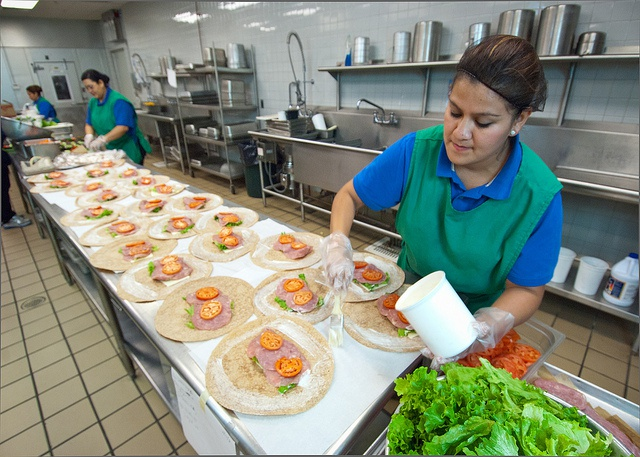Describe the objects in this image and their specific colors. I can see dining table in black, lightgray, tan, and gray tones, people in black, teal, and blue tones, cup in black, white, lightblue, darkgray, and lightgray tones, people in black, teal, and blue tones, and sink in black, gray, darkgray, and lightgray tones in this image. 